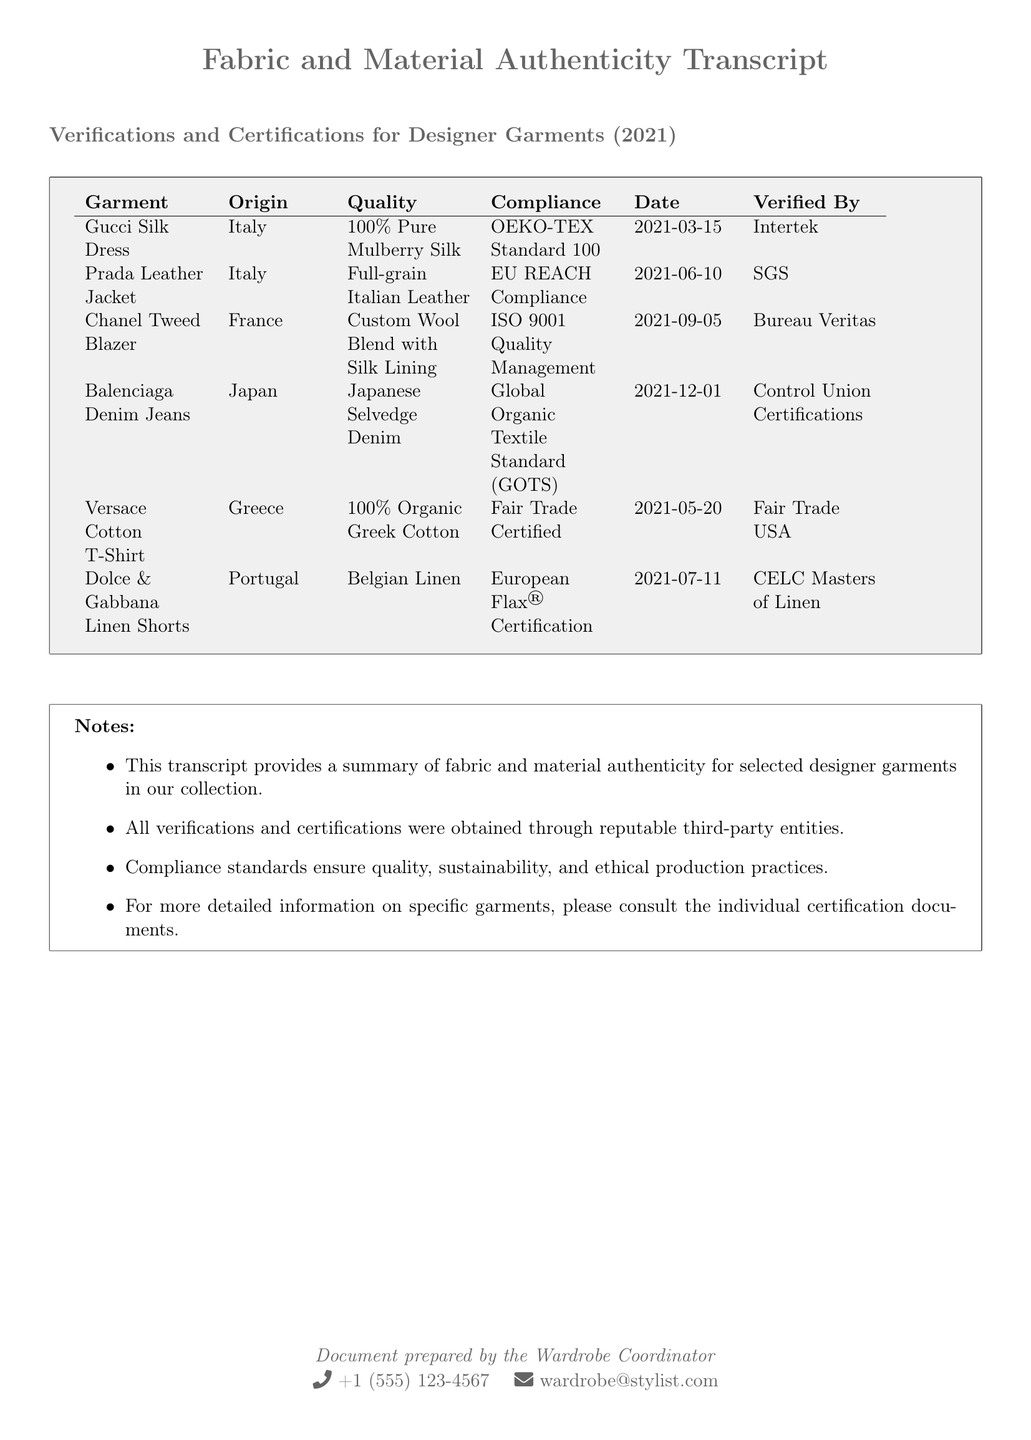what is the origin of the Gucci Silk Dress? The origin of the Gucci Silk Dress is listed in the document as Italy.
Answer: Italy what type of leather is used in the Prada Leather Jacket? The document specifies that the Prada Leather Jacket is made of Full-grain Italian Leather.
Answer: Full-grain Italian Leather what certification does the Balenciaga Denim Jeans comply with? The certification for the Balenciaga Denim Jeans is mentioned as Global Organic Textile Standard (GOTS).
Answer: Global Organic Textile Standard (GOTS) who verified the Chanel Tweed Blazer? The document states that the verification for the Chanel Tweed Blazer was done by Bureau Veritas.
Answer: Bureau Veritas what is the quality of the Versace Cotton T-Shirt? The quality of the Versace Cotton T-Shirt is noted as 100% Organic Greek Cotton.
Answer: 100% Organic Greek Cotton which garment has the date of verification on 2021-07-11? The document indicates that the Dolce & Gabbana Linen Shorts have the verification date of 2021-07-11.
Answer: Dolce & Gabbana Linen Shorts how many garments are listed in the document? The document includes a total of six garments in the verification table.
Answer: Six what compliance standard is associated with the Prada Leather Jacket? The compliance standard associated with the Prada Leather Jacket is EU REACH Compliance as stated in the document.
Answer: EU REACH Compliance what type of certification is mentioned for the Dolce & Gabbana Linen Shorts? The document mentions European Flax Certification for the Dolce & Gabbana Linen Shorts.
Answer: European Flax Certification 